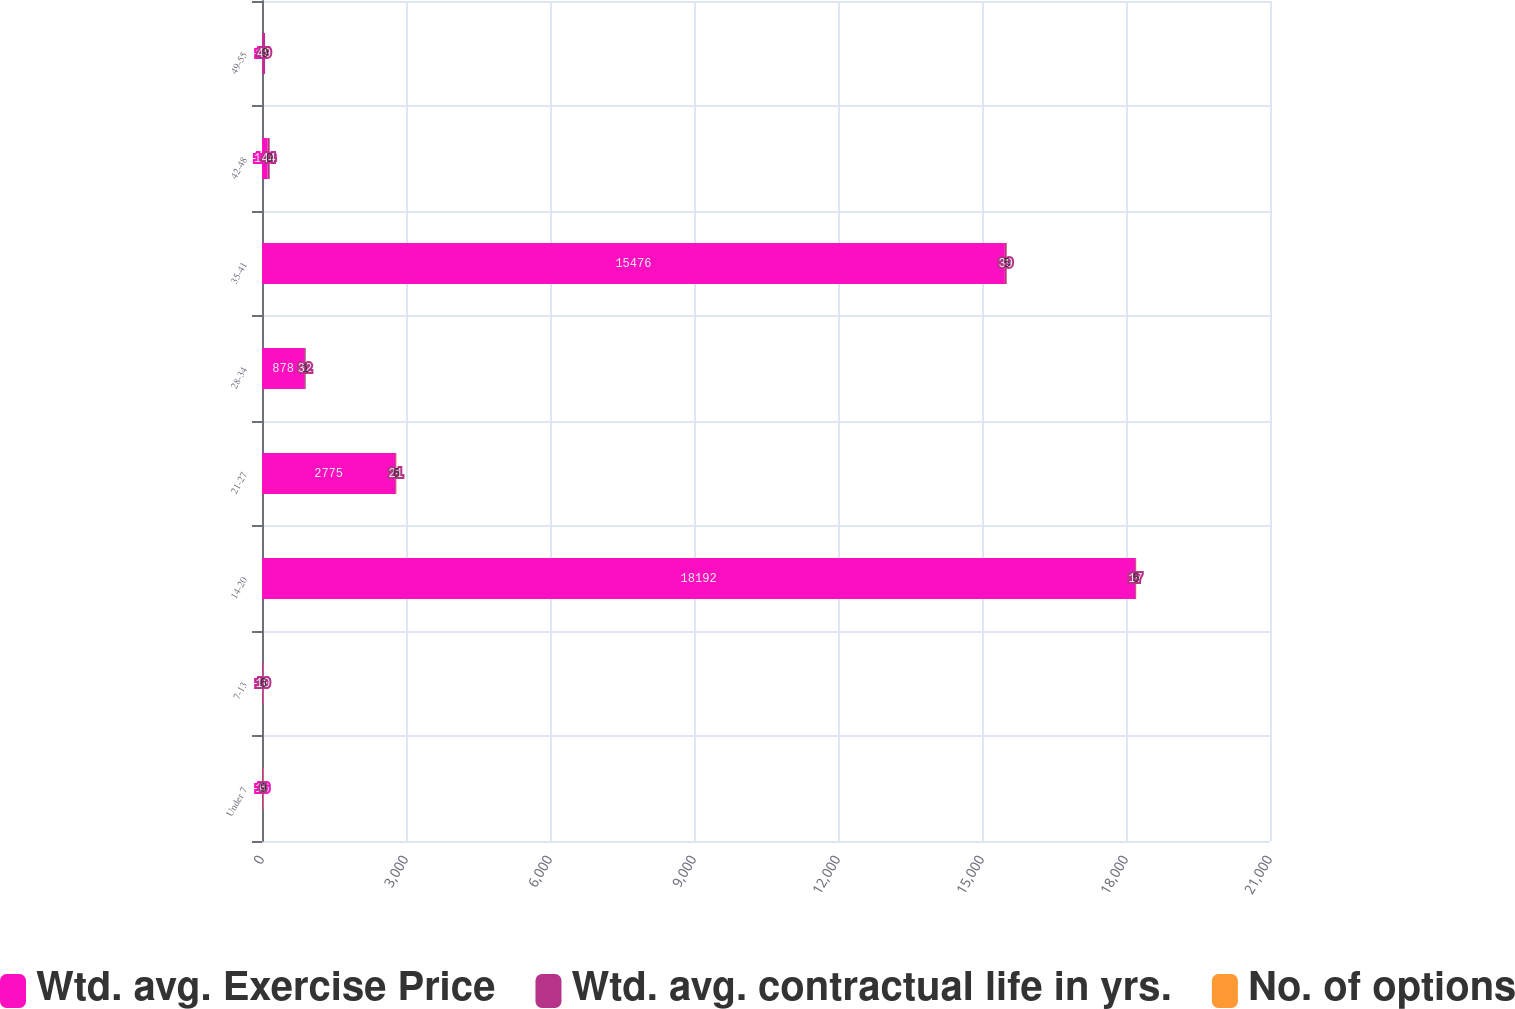Convert chart. <chart><loc_0><loc_0><loc_500><loc_500><stacked_bar_chart><ecel><fcel>Under 7<fcel>7-13<fcel>14-20<fcel>21-27<fcel>28-34<fcel>35-41<fcel>42-48<fcel>49-55<nl><fcel>Wtd. avg. Exercise Price<fcel>16<fcel>16<fcel>18192<fcel>2775<fcel>878<fcel>15476<fcel>116<fcel>15<nl><fcel>Wtd. avg. contractual life in yrs.<fcel>6<fcel>10<fcel>17<fcel>21<fcel>32<fcel>39<fcel>44<fcel>49<nl><fcel>No. of options<fcel>9<fcel>6<fcel>5<fcel>6<fcel>1<fcel>5<fcel>0<fcel>0<nl></chart> 